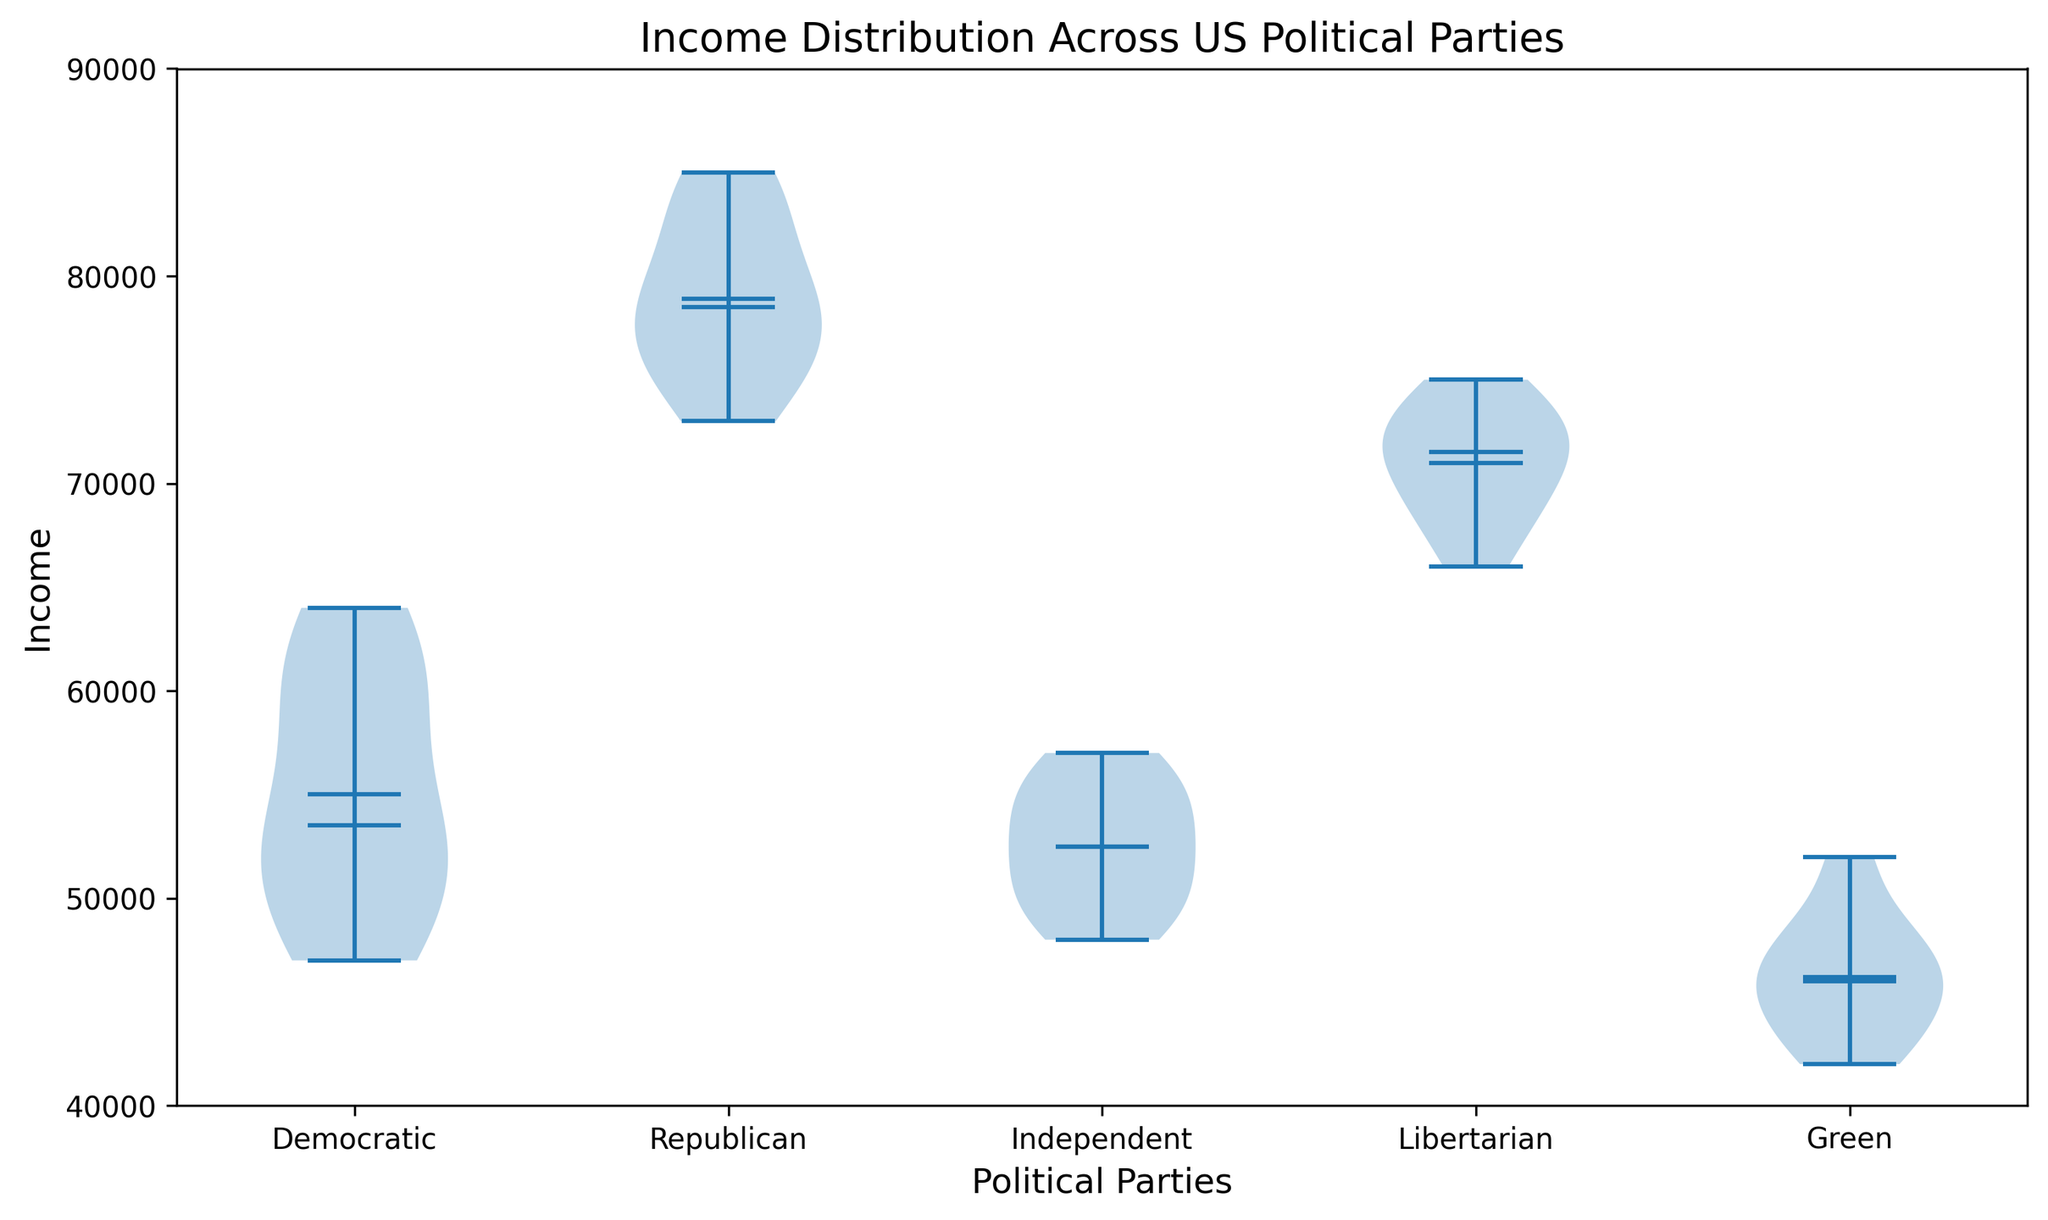What is the general trend of income distribution among the Democratic and Republican parties? Upon observing the violin plot, the income distribution for the Democratic party appears to be lower and less spread out compared to the Republican party, which shows higher and more spread income values. These differences are visually marked by the longer height of the violin for Republicans.
Answer: Republican incomes are generally higher and more varied Which political party exhibits the widest income distribution? The width of a violin plot at different levels reflects the density or distribution spread. The Republican party's violin plot is the widest, indicating a more spread distribution of income values.
Answer: Republican What is the median income for the Libertarian party as shown by the violin plot? The violin plot includes a horizontal line representing the median. For the Libertarian party, this median line is visibly present at around $71000.
Answer: $71000 How does the mean income of Independents compare to the mean income of Democrats as shown in the plot? Both the Democratic and Independent parties have their mean incomes indicated by a dot within the violins. Comparing the heights, the mean income of Independents is visibly lower than that of Democrats.
Answer: Independent mean income is lower Among the five political parties shown, which party has the smallest range of income distribution? The range in a violin plot can be inferred by the length of the 'violin'. The Green party has the shortest violin, indicating the smallest income range.
Answer: Green party Does any party show an income distribution that overlaps entirely within the interquartile range (IQR) of the Republican party? The interquartile range (IQR) is represented by the more substantial middle part of the violin. The Liberal party's distribution, for instance, does not overlap fully within the IQR of the Republican party.
Answer: No, the Green party does not have an IQR that overlaps within the Republican's IQR Which party has the highest median income? The median is marked by a line within the violin for each party. The party with the highest median income visually located at the highest position is the Republican party.
Answer: Republican What is the approximate range of incomes within which most Green party members fall? By observing the spread of the 'violin' for the Green party, most of the incomes fall within the $42000 to $48000 range.
Answer: $42000 to $48000 